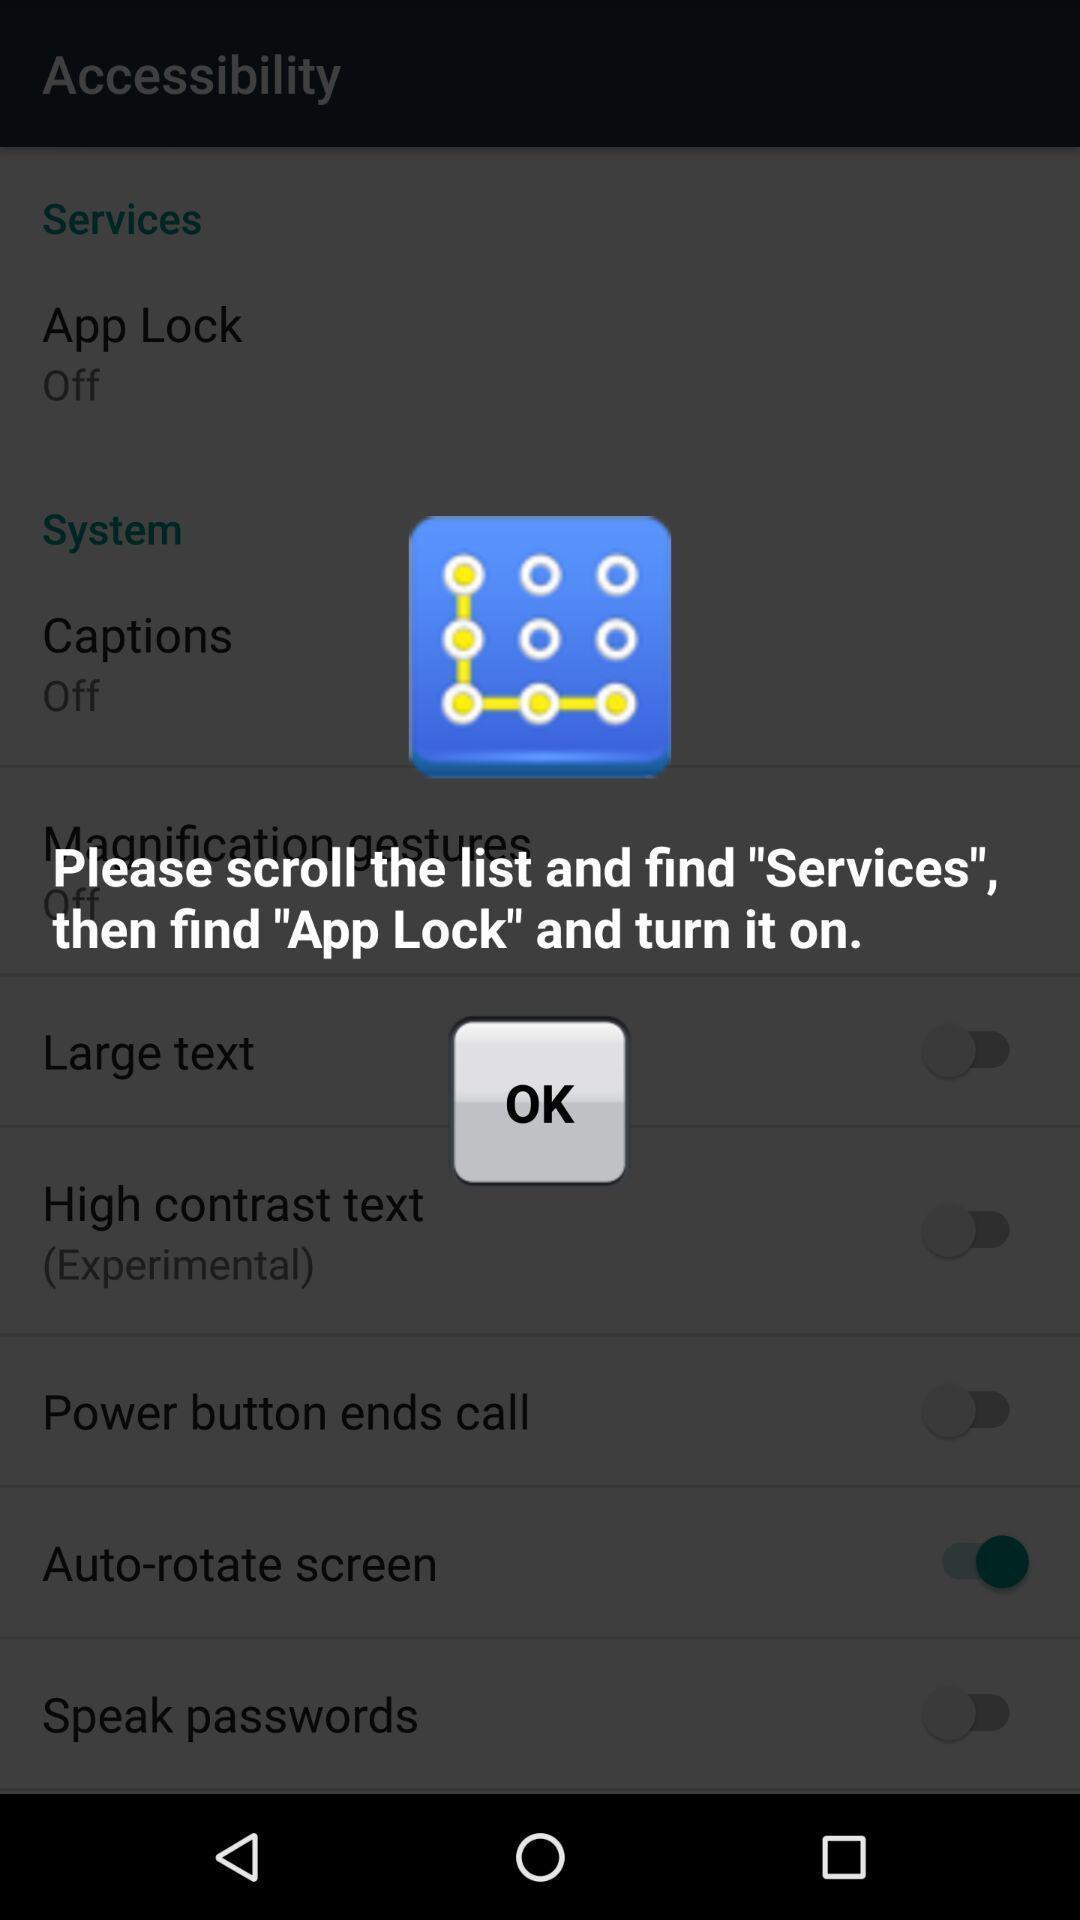Provide a detailed account of this screenshot. Screen displaying user guide notification. 